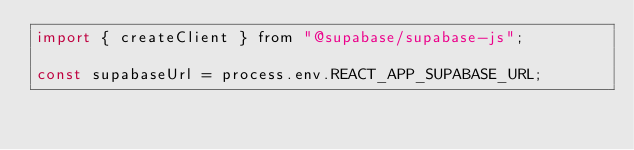<code> <loc_0><loc_0><loc_500><loc_500><_JavaScript_>import { createClient } from "@supabase/supabase-js";

const supabaseUrl = process.env.REACT_APP_SUPABASE_URL;</code> 